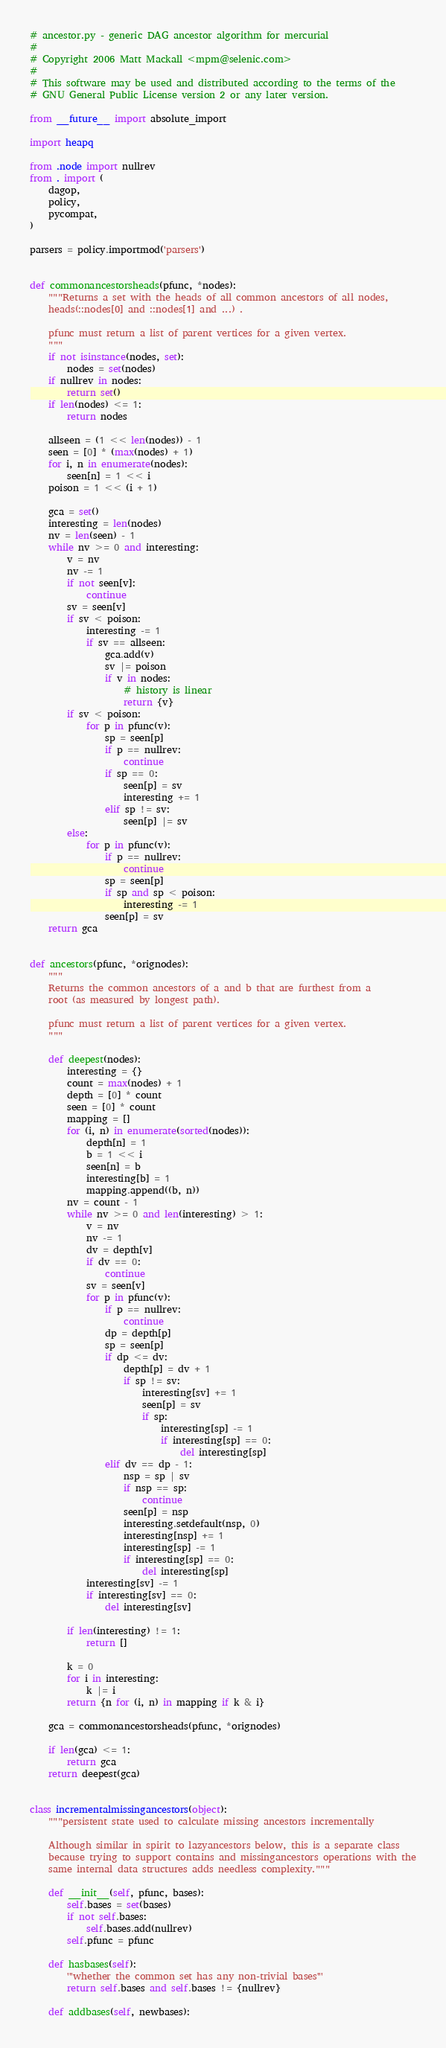<code> <loc_0><loc_0><loc_500><loc_500><_Python_># ancestor.py - generic DAG ancestor algorithm for mercurial
#
# Copyright 2006 Matt Mackall <mpm@selenic.com>
#
# This software may be used and distributed according to the terms of the
# GNU General Public License version 2 or any later version.

from __future__ import absolute_import

import heapq

from .node import nullrev
from . import (
    dagop,
    policy,
    pycompat,
)

parsers = policy.importmod('parsers')


def commonancestorsheads(pfunc, *nodes):
    """Returns a set with the heads of all common ancestors of all nodes,
    heads(::nodes[0] and ::nodes[1] and ...) .

    pfunc must return a list of parent vertices for a given vertex.
    """
    if not isinstance(nodes, set):
        nodes = set(nodes)
    if nullrev in nodes:
        return set()
    if len(nodes) <= 1:
        return nodes

    allseen = (1 << len(nodes)) - 1
    seen = [0] * (max(nodes) + 1)
    for i, n in enumerate(nodes):
        seen[n] = 1 << i
    poison = 1 << (i + 1)

    gca = set()
    interesting = len(nodes)
    nv = len(seen) - 1
    while nv >= 0 and interesting:
        v = nv
        nv -= 1
        if not seen[v]:
            continue
        sv = seen[v]
        if sv < poison:
            interesting -= 1
            if sv == allseen:
                gca.add(v)
                sv |= poison
                if v in nodes:
                    # history is linear
                    return {v}
        if sv < poison:
            for p in pfunc(v):
                sp = seen[p]
                if p == nullrev:
                    continue
                if sp == 0:
                    seen[p] = sv
                    interesting += 1
                elif sp != sv:
                    seen[p] |= sv
        else:
            for p in pfunc(v):
                if p == nullrev:
                    continue
                sp = seen[p]
                if sp and sp < poison:
                    interesting -= 1
                seen[p] = sv
    return gca


def ancestors(pfunc, *orignodes):
    """
    Returns the common ancestors of a and b that are furthest from a
    root (as measured by longest path).

    pfunc must return a list of parent vertices for a given vertex.
    """

    def deepest(nodes):
        interesting = {}
        count = max(nodes) + 1
        depth = [0] * count
        seen = [0] * count
        mapping = []
        for (i, n) in enumerate(sorted(nodes)):
            depth[n] = 1
            b = 1 << i
            seen[n] = b
            interesting[b] = 1
            mapping.append((b, n))
        nv = count - 1
        while nv >= 0 and len(interesting) > 1:
            v = nv
            nv -= 1
            dv = depth[v]
            if dv == 0:
                continue
            sv = seen[v]
            for p in pfunc(v):
                if p == nullrev:
                    continue
                dp = depth[p]
                sp = seen[p]
                if dp <= dv:
                    depth[p] = dv + 1
                    if sp != sv:
                        interesting[sv] += 1
                        seen[p] = sv
                        if sp:
                            interesting[sp] -= 1
                            if interesting[sp] == 0:
                                del interesting[sp]
                elif dv == dp - 1:
                    nsp = sp | sv
                    if nsp == sp:
                        continue
                    seen[p] = nsp
                    interesting.setdefault(nsp, 0)
                    interesting[nsp] += 1
                    interesting[sp] -= 1
                    if interesting[sp] == 0:
                        del interesting[sp]
            interesting[sv] -= 1
            if interesting[sv] == 0:
                del interesting[sv]

        if len(interesting) != 1:
            return []

        k = 0
        for i in interesting:
            k |= i
        return {n for (i, n) in mapping if k & i}

    gca = commonancestorsheads(pfunc, *orignodes)

    if len(gca) <= 1:
        return gca
    return deepest(gca)


class incrementalmissingancestors(object):
    """persistent state used to calculate missing ancestors incrementally

    Although similar in spirit to lazyancestors below, this is a separate class
    because trying to support contains and missingancestors operations with the
    same internal data structures adds needless complexity."""

    def __init__(self, pfunc, bases):
        self.bases = set(bases)
        if not self.bases:
            self.bases.add(nullrev)
        self.pfunc = pfunc

    def hasbases(self):
        '''whether the common set has any non-trivial bases'''
        return self.bases and self.bases != {nullrev}

    def addbases(self, newbases):</code> 